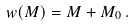Convert formula to latex. <formula><loc_0><loc_0><loc_500><loc_500>w ( M ) = M + M _ { 0 } \, .</formula> 